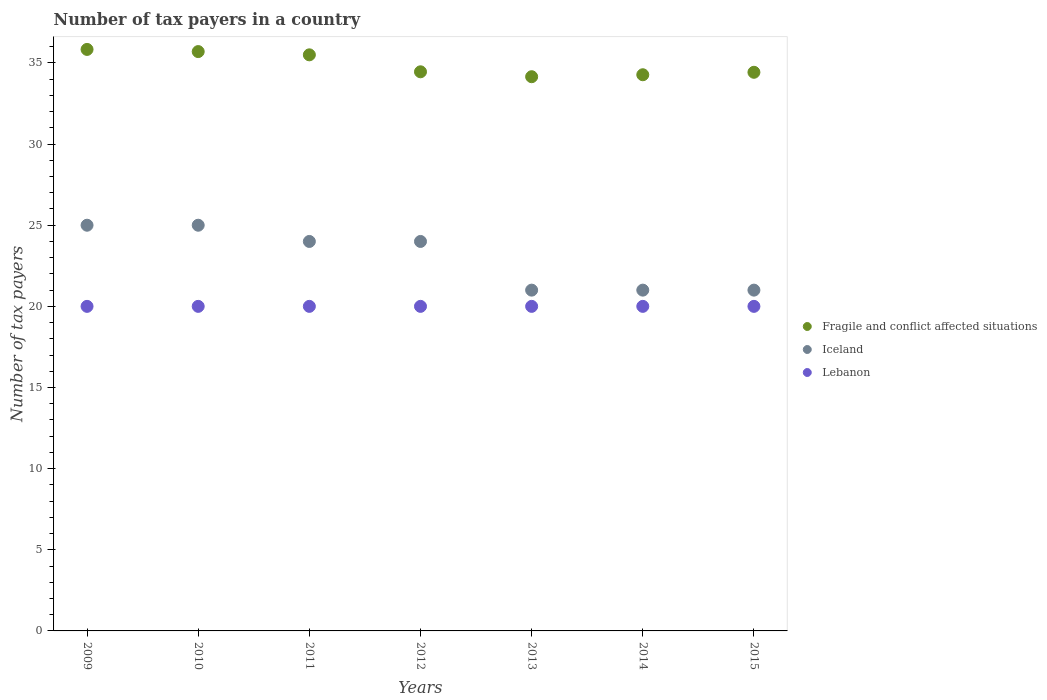Is the number of dotlines equal to the number of legend labels?
Offer a terse response. Yes. What is the number of tax payers in in Lebanon in 2014?
Your response must be concise. 20. Across all years, what is the maximum number of tax payers in in Lebanon?
Ensure brevity in your answer.  20. Across all years, what is the minimum number of tax payers in in Lebanon?
Your response must be concise. 20. What is the total number of tax payers in in Fragile and conflict affected situations in the graph?
Your answer should be compact. 244.34. What is the difference between the number of tax payers in in Fragile and conflict affected situations in 2012 and that in 2013?
Your answer should be very brief. 0.3. What is the difference between the number of tax payers in in Iceland in 2011 and the number of tax payers in in Fragile and conflict affected situations in 2012?
Make the answer very short. -10.45. In the year 2015, what is the difference between the number of tax payers in in Lebanon and number of tax payers in in Fragile and conflict affected situations?
Your response must be concise. -14.42. What is the ratio of the number of tax payers in in Iceland in 2010 to that in 2014?
Your answer should be compact. 1.19. Is the number of tax payers in in Lebanon in 2010 less than that in 2014?
Your answer should be compact. No. What is the difference between the highest and the second highest number of tax payers in in Iceland?
Provide a succinct answer. 0. What is the difference between the highest and the lowest number of tax payers in in Fragile and conflict affected situations?
Your answer should be compact. 1.68. In how many years, is the number of tax payers in in Lebanon greater than the average number of tax payers in in Lebanon taken over all years?
Give a very brief answer. 0. Is the sum of the number of tax payers in in Fragile and conflict affected situations in 2009 and 2013 greater than the maximum number of tax payers in in Iceland across all years?
Make the answer very short. Yes. Does the number of tax payers in in Lebanon monotonically increase over the years?
Your answer should be very brief. No. Is the number of tax payers in in Iceland strictly greater than the number of tax payers in in Fragile and conflict affected situations over the years?
Ensure brevity in your answer.  No. Is the number of tax payers in in Fragile and conflict affected situations strictly less than the number of tax payers in in Lebanon over the years?
Your answer should be compact. No. Does the graph contain any zero values?
Offer a very short reply. No. How many legend labels are there?
Give a very brief answer. 3. How are the legend labels stacked?
Your response must be concise. Vertical. What is the title of the graph?
Your answer should be very brief. Number of tax payers in a country. Does "Sierra Leone" appear as one of the legend labels in the graph?
Give a very brief answer. No. What is the label or title of the X-axis?
Offer a very short reply. Years. What is the label or title of the Y-axis?
Provide a succinct answer. Number of tax payers. What is the Number of tax payers of Fragile and conflict affected situations in 2009?
Make the answer very short. 35.83. What is the Number of tax payers in Iceland in 2009?
Provide a succinct answer. 25. What is the Number of tax payers of Lebanon in 2009?
Keep it short and to the point. 20. What is the Number of tax payers in Fragile and conflict affected situations in 2010?
Offer a terse response. 35.7. What is the Number of tax payers of Lebanon in 2010?
Offer a terse response. 20. What is the Number of tax payers in Fragile and conflict affected situations in 2011?
Your answer should be compact. 35.5. What is the Number of tax payers of Lebanon in 2011?
Your answer should be compact. 20. What is the Number of tax payers in Fragile and conflict affected situations in 2012?
Provide a short and direct response. 34.45. What is the Number of tax payers of Lebanon in 2012?
Your answer should be very brief. 20. What is the Number of tax payers of Fragile and conflict affected situations in 2013?
Offer a very short reply. 34.15. What is the Number of tax payers of Lebanon in 2013?
Offer a very short reply. 20. What is the Number of tax payers in Fragile and conflict affected situations in 2014?
Your answer should be compact. 34.27. What is the Number of tax payers of Iceland in 2014?
Your response must be concise. 21. What is the Number of tax payers of Lebanon in 2014?
Ensure brevity in your answer.  20. What is the Number of tax payers in Fragile and conflict affected situations in 2015?
Provide a succinct answer. 34.42. What is the Number of tax payers in Lebanon in 2015?
Give a very brief answer. 20. Across all years, what is the maximum Number of tax payers in Fragile and conflict affected situations?
Your answer should be compact. 35.83. Across all years, what is the maximum Number of tax payers in Lebanon?
Offer a very short reply. 20. Across all years, what is the minimum Number of tax payers of Fragile and conflict affected situations?
Offer a very short reply. 34.15. What is the total Number of tax payers in Fragile and conflict affected situations in the graph?
Provide a short and direct response. 244.34. What is the total Number of tax payers in Iceland in the graph?
Offer a very short reply. 161. What is the total Number of tax payers in Lebanon in the graph?
Keep it short and to the point. 140. What is the difference between the Number of tax payers of Fragile and conflict affected situations in 2009 and that in 2010?
Ensure brevity in your answer.  0.13. What is the difference between the Number of tax payers in Iceland in 2009 and that in 2010?
Offer a terse response. 0. What is the difference between the Number of tax payers in Lebanon in 2009 and that in 2011?
Ensure brevity in your answer.  0. What is the difference between the Number of tax payers in Fragile and conflict affected situations in 2009 and that in 2012?
Keep it short and to the point. 1.38. What is the difference between the Number of tax payers of Iceland in 2009 and that in 2012?
Your answer should be very brief. 1. What is the difference between the Number of tax payers in Fragile and conflict affected situations in 2009 and that in 2013?
Make the answer very short. 1.68. What is the difference between the Number of tax payers in Lebanon in 2009 and that in 2013?
Offer a very short reply. 0. What is the difference between the Number of tax payers in Fragile and conflict affected situations in 2009 and that in 2014?
Offer a terse response. 1.56. What is the difference between the Number of tax payers of Iceland in 2009 and that in 2014?
Make the answer very short. 4. What is the difference between the Number of tax payers in Lebanon in 2009 and that in 2014?
Provide a succinct answer. 0. What is the difference between the Number of tax payers in Fragile and conflict affected situations in 2009 and that in 2015?
Provide a short and direct response. 1.41. What is the difference between the Number of tax payers in Fragile and conflict affected situations in 2010 and that in 2012?
Provide a short and direct response. 1.25. What is the difference between the Number of tax payers in Fragile and conflict affected situations in 2010 and that in 2013?
Make the answer very short. 1.55. What is the difference between the Number of tax payers of Iceland in 2010 and that in 2013?
Your response must be concise. 4. What is the difference between the Number of tax payers of Fragile and conflict affected situations in 2010 and that in 2014?
Your answer should be very brief. 1.43. What is the difference between the Number of tax payers in Iceland in 2010 and that in 2014?
Your answer should be compact. 4. What is the difference between the Number of tax payers of Lebanon in 2010 and that in 2014?
Offer a very short reply. 0. What is the difference between the Number of tax payers of Fragile and conflict affected situations in 2010 and that in 2015?
Your answer should be compact. 1.28. What is the difference between the Number of tax payers of Iceland in 2010 and that in 2015?
Your answer should be compact. 4. What is the difference between the Number of tax payers in Lebanon in 2010 and that in 2015?
Ensure brevity in your answer.  0. What is the difference between the Number of tax payers in Fragile and conflict affected situations in 2011 and that in 2012?
Your answer should be compact. 1.05. What is the difference between the Number of tax payers of Iceland in 2011 and that in 2012?
Make the answer very short. 0. What is the difference between the Number of tax payers in Fragile and conflict affected situations in 2011 and that in 2013?
Keep it short and to the point. 1.35. What is the difference between the Number of tax payers of Iceland in 2011 and that in 2013?
Offer a terse response. 3. What is the difference between the Number of tax payers of Fragile and conflict affected situations in 2011 and that in 2014?
Keep it short and to the point. 1.23. What is the difference between the Number of tax payers in Iceland in 2011 and that in 2014?
Your response must be concise. 3. What is the difference between the Number of tax payers of Fragile and conflict affected situations in 2011 and that in 2015?
Ensure brevity in your answer.  1.08. What is the difference between the Number of tax payers of Fragile and conflict affected situations in 2012 and that in 2013?
Your answer should be very brief. 0.3. What is the difference between the Number of tax payers in Fragile and conflict affected situations in 2012 and that in 2014?
Give a very brief answer. 0.18. What is the difference between the Number of tax payers of Iceland in 2012 and that in 2014?
Your answer should be very brief. 3. What is the difference between the Number of tax payers in Lebanon in 2012 and that in 2014?
Provide a succinct answer. 0. What is the difference between the Number of tax payers of Fragile and conflict affected situations in 2012 and that in 2015?
Your answer should be very brief. 0.03. What is the difference between the Number of tax payers of Iceland in 2012 and that in 2015?
Provide a succinct answer. 3. What is the difference between the Number of tax payers in Lebanon in 2012 and that in 2015?
Give a very brief answer. 0. What is the difference between the Number of tax payers of Fragile and conflict affected situations in 2013 and that in 2014?
Offer a very short reply. -0.12. What is the difference between the Number of tax payers in Lebanon in 2013 and that in 2014?
Give a very brief answer. 0. What is the difference between the Number of tax payers of Fragile and conflict affected situations in 2013 and that in 2015?
Offer a terse response. -0.27. What is the difference between the Number of tax payers in Iceland in 2013 and that in 2015?
Offer a terse response. 0. What is the difference between the Number of tax payers of Fragile and conflict affected situations in 2014 and that in 2015?
Your response must be concise. -0.15. What is the difference between the Number of tax payers of Lebanon in 2014 and that in 2015?
Provide a succinct answer. 0. What is the difference between the Number of tax payers in Fragile and conflict affected situations in 2009 and the Number of tax payers in Iceland in 2010?
Offer a very short reply. 10.83. What is the difference between the Number of tax payers in Fragile and conflict affected situations in 2009 and the Number of tax payers in Lebanon in 2010?
Provide a short and direct response. 15.83. What is the difference between the Number of tax payers in Fragile and conflict affected situations in 2009 and the Number of tax payers in Iceland in 2011?
Make the answer very short. 11.83. What is the difference between the Number of tax payers in Fragile and conflict affected situations in 2009 and the Number of tax payers in Lebanon in 2011?
Provide a succinct answer. 15.83. What is the difference between the Number of tax payers in Fragile and conflict affected situations in 2009 and the Number of tax payers in Iceland in 2012?
Keep it short and to the point. 11.83. What is the difference between the Number of tax payers in Fragile and conflict affected situations in 2009 and the Number of tax payers in Lebanon in 2012?
Offer a very short reply. 15.83. What is the difference between the Number of tax payers of Iceland in 2009 and the Number of tax payers of Lebanon in 2012?
Offer a very short reply. 5. What is the difference between the Number of tax payers in Fragile and conflict affected situations in 2009 and the Number of tax payers in Iceland in 2013?
Your answer should be compact. 14.83. What is the difference between the Number of tax payers in Fragile and conflict affected situations in 2009 and the Number of tax payers in Lebanon in 2013?
Offer a very short reply. 15.83. What is the difference between the Number of tax payers of Fragile and conflict affected situations in 2009 and the Number of tax payers of Iceland in 2014?
Your answer should be very brief. 14.83. What is the difference between the Number of tax payers in Fragile and conflict affected situations in 2009 and the Number of tax payers in Lebanon in 2014?
Your answer should be compact. 15.83. What is the difference between the Number of tax payers of Fragile and conflict affected situations in 2009 and the Number of tax payers of Iceland in 2015?
Provide a short and direct response. 14.83. What is the difference between the Number of tax payers of Fragile and conflict affected situations in 2009 and the Number of tax payers of Lebanon in 2015?
Make the answer very short. 15.83. What is the difference between the Number of tax payers of Iceland in 2009 and the Number of tax payers of Lebanon in 2015?
Your answer should be compact. 5. What is the difference between the Number of tax payers of Fragile and conflict affected situations in 2010 and the Number of tax payers of Iceland in 2011?
Provide a succinct answer. 11.7. What is the difference between the Number of tax payers of Iceland in 2010 and the Number of tax payers of Lebanon in 2011?
Your answer should be compact. 5. What is the difference between the Number of tax payers of Fragile and conflict affected situations in 2010 and the Number of tax payers of Lebanon in 2012?
Your answer should be compact. 15.7. What is the difference between the Number of tax payers of Fragile and conflict affected situations in 2010 and the Number of tax payers of Iceland in 2013?
Ensure brevity in your answer.  14.7. What is the difference between the Number of tax payers of Fragile and conflict affected situations in 2010 and the Number of tax payers of Lebanon in 2013?
Provide a short and direct response. 15.7. What is the difference between the Number of tax payers in Iceland in 2010 and the Number of tax payers in Lebanon in 2013?
Your answer should be very brief. 5. What is the difference between the Number of tax payers in Fragile and conflict affected situations in 2010 and the Number of tax payers in Iceland in 2014?
Offer a very short reply. 14.7. What is the difference between the Number of tax payers in Fragile and conflict affected situations in 2010 and the Number of tax payers in Lebanon in 2014?
Your response must be concise. 15.7. What is the difference between the Number of tax payers in Iceland in 2010 and the Number of tax payers in Lebanon in 2014?
Your answer should be very brief. 5. What is the difference between the Number of tax payers in Fragile and conflict affected situations in 2011 and the Number of tax payers in Iceland in 2012?
Keep it short and to the point. 11.5. What is the difference between the Number of tax payers of Fragile and conflict affected situations in 2011 and the Number of tax payers of Lebanon in 2012?
Your response must be concise. 15.5. What is the difference between the Number of tax payers in Iceland in 2011 and the Number of tax payers in Lebanon in 2012?
Offer a terse response. 4. What is the difference between the Number of tax payers in Fragile and conflict affected situations in 2011 and the Number of tax payers in Lebanon in 2013?
Provide a short and direct response. 15.5. What is the difference between the Number of tax payers in Iceland in 2011 and the Number of tax payers in Lebanon in 2013?
Make the answer very short. 4. What is the difference between the Number of tax payers of Fragile and conflict affected situations in 2011 and the Number of tax payers of Lebanon in 2014?
Give a very brief answer. 15.5. What is the difference between the Number of tax payers of Fragile and conflict affected situations in 2011 and the Number of tax payers of Lebanon in 2015?
Your response must be concise. 15.5. What is the difference between the Number of tax payers in Fragile and conflict affected situations in 2012 and the Number of tax payers in Iceland in 2013?
Your answer should be very brief. 13.45. What is the difference between the Number of tax payers of Fragile and conflict affected situations in 2012 and the Number of tax payers of Lebanon in 2013?
Offer a very short reply. 14.45. What is the difference between the Number of tax payers of Iceland in 2012 and the Number of tax payers of Lebanon in 2013?
Keep it short and to the point. 4. What is the difference between the Number of tax payers in Fragile and conflict affected situations in 2012 and the Number of tax payers in Iceland in 2014?
Your answer should be very brief. 13.45. What is the difference between the Number of tax payers in Fragile and conflict affected situations in 2012 and the Number of tax payers in Lebanon in 2014?
Provide a succinct answer. 14.45. What is the difference between the Number of tax payers in Iceland in 2012 and the Number of tax payers in Lebanon in 2014?
Give a very brief answer. 4. What is the difference between the Number of tax payers of Fragile and conflict affected situations in 2012 and the Number of tax payers of Iceland in 2015?
Provide a succinct answer. 13.45. What is the difference between the Number of tax payers in Fragile and conflict affected situations in 2012 and the Number of tax payers in Lebanon in 2015?
Make the answer very short. 14.45. What is the difference between the Number of tax payers in Fragile and conflict affected situations in 2013 and the Number of tax payers in Iceland in 2014?
Give a very brief answer. 13.15. What is the difference between the Number of tax payers of Fragile and conflict affected situations in 2013 and the Number of tax payers of Lebanon in 2014?
Make the answer very short. 14.15. What is the difference between the Number of tax payers of Fragile and conflict affected situations in 2013 and the Number of tax payers of Iceland in 2015?
Provide a succinct answer. 13.15. What is the difference between the Number of tax payers of Fragile and conflict affected situations in 2013 and the Number of tax payers of Lebanon in 2015?
Your response must be concise. 14.15. What is the difference between the Number of tax payers of Fragile and conflict affected situations in 2014 and the Number of tax payers of Iceland in 2015?
Provide a short and direct response. 13.27. What is the difference between the Number of tax payers of Fragile and conflict affected situations in 2014 and the Number of tax payers of Lebanon in 2015?
Offer a terse response. 14.27. What is the average Number of tax payers in Fragile and conflict affected situations per year?
Give a very brief answer. 34.91. What is the average Number of tax payers of Iceland per year?
Offer a terse response. 23. In the year 2009, what is the difference between the Number of tax payers in Fragile and conflict affected situations and Number of tax payers in Iceland?
Provide a succinct answer. 10.83. In the year 2009, what is the difference between the Number of tax payers of Fragile and conflict affected situations and Number of tax payers of Lebanon?
Make the answer very short. 15.83. In the year 2010, what is the difference between the Number of tax payers of Fragile and conflict affected situations and Number of tax payers of Lebanon?
Provide a succinct answer. 15.7. In the year 2010, what is the difference between the Number of tax payers of Iceland and Number of tax payers of Lebanon?
Provide a succinct answer. 5. In the year 2012, what is the difference between the Number of tax payers in Fragile and conflict affected situations and Number of tax payers in Iceland?
Ensure brevity in your answer.  10.45. In the year 2012, what is the difference between the Number of tax payers in Fragile and conflict affected situations and Number of tax payers in Lebanon?
Give a very brief answer. 14.45. In the year 2012, what is the difference between the Number of tax payers in Iceland and Number of tax payers in Lebanon?
Your answer should be compact. 4. In the year 2013, what is the difference between the Number of tax payers of Fragile and conflict affected situations and Number of tax payers of Iceland?
Your answer should be very brief. 13.15. In the year 2013, what is the difference between the Number of tax payers in Fragile and conflict affected situations and Number of tax payers in Lebanon?
Make the answer very short. 14.15. In the year 2014, what is the difference between the Number of tax payers in Fragile and conflict affected situations and Number of tax payers in Iceland?
Offer a very short reply. 13.27. In the year 2014, what is the difference between the Number of tax payers in Fragile and conflict affected situations and Number of tax payers in Lebanon?
Offer a very short reply. 14.27. In the year 2014, what is the difference between the Number of tax payers of Iceland and Number of tax payers of Lebanon?
Make the answer very short. 1. In the year 2015, what is the difference between the Number of tax payers in Fragile and conflict affected situations and Number of tax payers in Iceland?
Make the answer very short. 13.42. In the year 2015, what is the difference between the Number of tax payers in Fragile and conflict affected situations and Number of tax payers in Lebanon?
Keep it short and to the point. 14.42. In the year 2015, what is the difference between the Number of tax payers of Iceland and Number of tax payers of Lebanon?
Give a very brief answer. 1. What is the ratio of the Number of tax payers of Fragile and conflict affected situations in 2009 to that in 2010?
Ensure brevity in your answer.  1. What is the ratio of the Number of tax payers of Iceland in 2009 to that in 2010?
Offer a terse response. 1. What is the ratio of the Number of tax payers of Lebanon in 2009 to that in 2010?
Keep it short and to the point. 1. What is the ratio of the Number of tax payers of Fragile and conflict affected situations in 2009 to that in 2011?
Provide a succinct answer. 1.01. What is the ratio of the Number of tax payers of Iceland in 2009 to that in 2011?
Give a very brief answer. 1.04. What is the ratio of the Number of tax payers of Iceland in 2009 to that in 2012?
Your answer should be very brief. 1.04. What is the ratio of the Number of tax payers in Lebanon in 2009 to that in 2012?
Your response must be concise. 1. What is the ratio of the Number of tax payers of Fragile and conflict affected situations in 2009 to that in 2013?
Keep it short and to the point. 1.05. What is the ratio of the Number of tax payers in Iceland in 2009 to that in 2013?
Offer a very short reply. 1.19. What is the ratio of the Number of tax payers of Lebanon in 2009 to that in 2013?
Provide a succinct answer. 1. What is the ratio of the Number of tax payers of Fragile and conflict affected situations in 2009 to that in 2014?
Provide a short and direct response. 1.05. What is the ratio of the Number of tax payers of Iceland in 2009 to that in 2014?
Your response must be concise. 1.19. What is the ratio of the Number of tax payers in Fragile and conflict affected situations in 2009 to that in 2015?
Offer a very short reply. 1.04. What is the ratio of the Number of tax payers in Iceland in 2009 to that in 2015?
Make the answer very short. 1.19. What is the ratio of the Number of tax payers in Fragile and conflict affected situations in 2010 to that in 2011?
Provide a short and direct response. 1.01. What is the ratio of the Number of tax payers in Iceland in 2010 to that in 2011?
Offer a terse response. 1.04. What is the ratio of the Number of tax payers of Lebanon in 2010 to that in 2011?
Provide a succinct answer. 1. What is the ratio of the Number of tax payers in Fragile and conflict affected situations in 2010 to that in 2012?
Your answer should be very brief. 1.04. What is the ratio of the Number of tax payers in Iceland in 2010 to that in 2012?
Make the answer very short. 1.04. What is the ratio of the Number of tax payers of Fragile and conflict affected situations in 2010 to that in 2013?
Provide a succinct answer. 1.05. What is the ratio of the Number of tax payers of Iceland in 2010 to that in 2013?
Your answer should be compact. 1.19. What is the ratio of the Number of tax payers in Lebanon in 2010 to that in 2013?
Offer a very short reply. 1. What is the ratio of the Number of tax payers of Fragile and conflict affected situations in 2010 to that in 2014?
Your answer should be very brief. 1.04. What is the ratio of the Number of tax payers of Iceland in 2010 to that in 2014?
Your answer should be very brief. 1.19. What is the ratio of the Number of tax payers of Lebanon in 2010 to that in 2014?
Offer a terse response. 1. What is the ratio of the Number of tax payers of Fragile and conflict affected situations in 2010 to that in 2015?
Your answer should be very brief. 1.04. What is the ratio of the Number of tax payers in Iceland in 2010 to that in 2015?
Your response must be concise. 1.19. What is the ratio of the Number of tax payers of Fragile and conflict affected situations in 2011 to that in 2012?
Your response must be concise. 1.03. What is the ratio of the Number of tax payers of Fragile and conflict affected situations in 2011 to that in 2013?
Your answer should be compact. 1.04. What is the ratio of the Number of tax payers in Iceland in 2011 to that in 2013?
Provide a short and direct response. 1.14. What is the ratio of the Number of tax payers in Lebanon in 2011 to that in 2013?
Your response must be concise. 1. What is the ratio of the Number of tax payers of Fragile and conflict affected situations in 2011 to that in 2014?
Keep it short and to the point. 1.04. What is the ratio of the Number of tax payers of Fragile and conflict affected situations in 2011 to that in 2015?
Give a very brief answer. 1.03. What is the ratio of the Number of tax payers of Iceland in 2011 to that in 2015?
Provide a short and direct response. 1.14. What is the ratio of the Number of tax payers in Lebanon in 2011 to that in 2015?
Provide a short and direct response. 1. What is the ratio of the Number of tax payers in Fragile and conflict affected situations in 2012 to that in 2013?
Give a very brief answer. 1.01. What is the ratio of the Number of tax payers in Fragile and conflict affected situations in 2012 to that in 2015?
Offer a very short reply. 1. What is the ratio of the Number of tax payers of Lebanon in 2012 to that in 2015?
Provide a succinct answer. 1. What is the ratio of the Number of tax payers in Iceland in 2013 to that in 2014?
Your answer should be very brief. 1. What is the ratio of the Number of tax payers in Lebanon in 2013 to that in 2014?
Your answer should be very brief. 1. What is the ratio of the Number of tax payers in Fragile and conflict affected situations in 2013 to that in 2015?
Offer a terse response. 0.99. What is the ratio of the Number of tax payers of Fragile and conflict affected situations in 2014 to that in 2015?
Provide a short and direct response. 1. What is the ratio of the Number of tax payers in Iceland in 2014 to that in 2015?
Give a very brief answer. 1. What is the ratio of the Number of tax payers in Lebanon in 2014 to that in 2015?
Offer a terse response. 1. What is the difference between the highest and the second highest Number of tax payers in Fragile and conflict affected situations?
Keep it short and to the point. 0.13. What is the difference between the highest and the second highest Number of tax payers of Iceland?
Provide a succinct answer. 0. What is the difference between the highest and the lowest Number of tax payers in Fragile and conflict affected situations?
Ensure brevity in your answer.  1.68. 